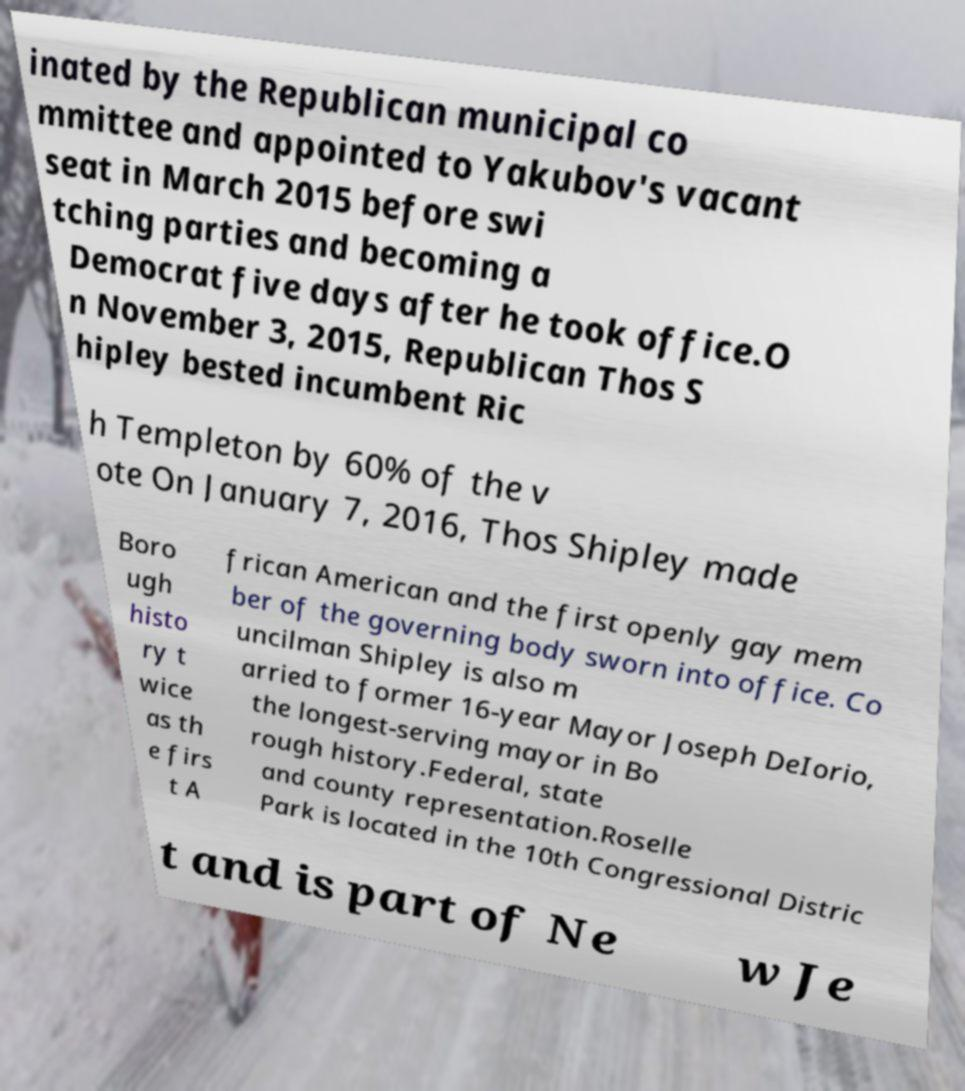Could you extract and type out the text from this image? inated by the Republican municipal co mmittee and appointed to Yakubov's vacant seat in March 2015 before swi tching parties and becoming a Democrat five days after he took office.O n November 3, 2015, Republican Thos S hipley bested incumbent Ric h Templeton by 60% of the v ote On January 7, 2016, Thos Shipley made Boro ugh histo ry t wice as th e firs t A frican American and the first openly gay mem ber of the governing body sworn into office. Co uncilman Shipley is also m arried to former 16-year Mayor Joseph DeIorio, the longest-serving mayor in Bo rough history.Federal, state and county representation.Roselle Park is located in the 10th Congressional Distric t and is part of Ne w Je 